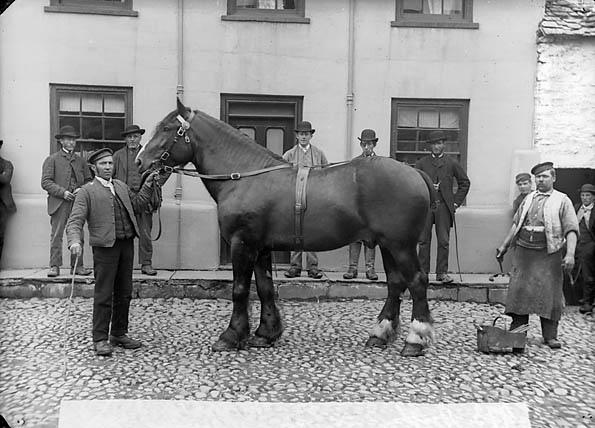What kind of horse is this?
Keep it brief. Work. What are those things on the horse's backs called?
Concise answer only. Saddle. How many men are standing up?
Short answer required. 10. Is this a small animal?
Answer briefly. No. What color is the horse?
Write a very short answer. Brown. Is the horse moving?
Keep it brief. No. What is strapped to the horse?
Be succinct. Harness. Is this a vintage photo?
Be succinct. Yes. 